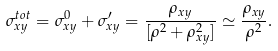<formula> <loc_0><loc_0><loc_500><loc_500>\sigma ^ { t o t } _ { x y } = \sigma ^ { 0 } _ { x y } + \sigma ^ { \prime } _ { x y } = \frac { \rho _ { x y } } { [ \rho ^ { 2 } + \rho _ { x y } ^ { 2 } ] } \simeq \frac { \rho _ { x y } } { \rho ^ { 2 } } .</formula> 